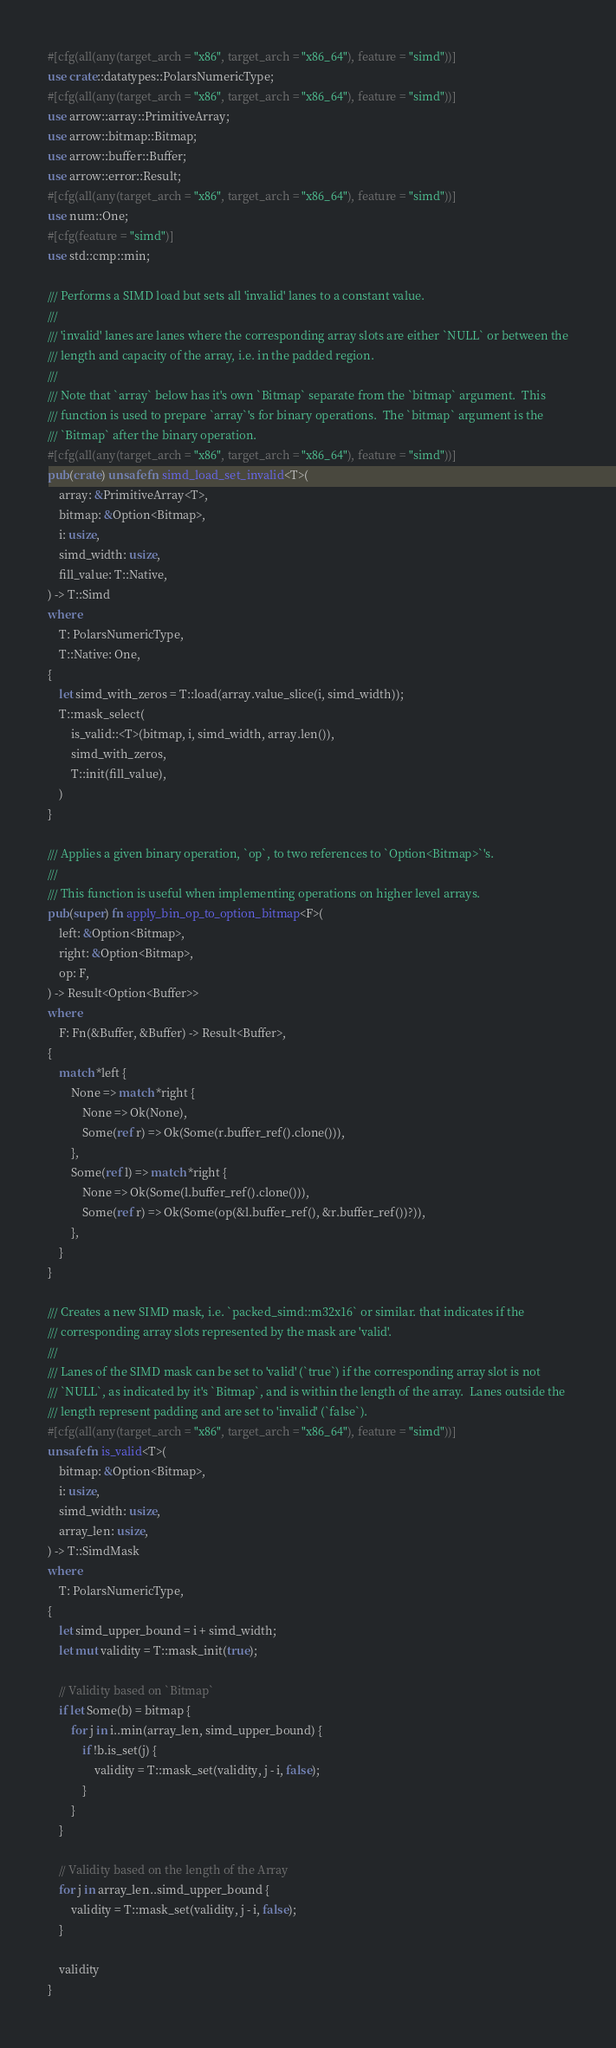Convert code to text. <code><loc_0><loc_0><loc_500><loc_500><_Rust_>#[cfg(all(any(target_arch = "x86", target_arch = "x86_64"), feature = "simd"))]
use crate::datatypes::PolarsNumericType;
#[cfg(all(any(target_arch = "x86", target_arch = "x86_64"), feature = "simd"))]
use arrow::array::PrimitiveArray;
use arrow::bitmap::Bitmap;
use arrow::buffer::Buffer;
use arrow::error::Result;
#[cfg(all(any(target_arch = "x86", target_arch = "x86_64"), feature = "simd"))]
use num::One;
#[cfg(feature = "simd")]
use std::cmp::min;

/// Performs a SIMD load but sets all 'invalid' lanes to a constant value.
///
/// 'invalid' lanes are lanes where the corresponding array slots are either `NULL` or between the
/// length and capacity of the array, i.e. in the padded region.
///
/// Note that `array` below has it's own `Bitmap` separate from the `bitmap` argument.  This
/// function is used to prepare `array`'s for binary operations.  The `bitmap` argument is the
/// `Bitmap` after the binary operation.
#[cfg(all(any(target_arch = "x86", target_arch = "x86_64"), feature = "simd"))]
pub(crate) unsafe fn simd_load_set_invalid<T>(
    array: &PrimitiveArray<T>,
    bitmap: &Option<Bitmap>,
    i: usize,
    simd_width: usize,
    fill_value: T::Native,
) -> T::Simd
where
    T: PolarsNumericType,
    T::Native: One,
{
    let simd_with_zeros = T::load(array.value_slice(i, simd_width));
    T::mask_select(
        is_valid::<T>(bitmap, i, simd_width, array.len()),
        simd_with_zeros,
        T::init(fill_value),
    )
}

/// Applies a given binary operation, `op`, to two references to `Option<Bitmap>`'s.
///
/// This function is useful when implementing operations on higher level arrays.
pub(super) fn apply_bin_op_to_option_bitmap<F>(
    left: &Option<Bitmap>,
    right: &Option<Bitmap>,
    op: F,
) -> Result<Option<Buffer>>
where
    F: Fn(&Buffer, &Buffer) -> Result<Buffer>,
{
    match *left {
        None => match *right {
            None => Ok(None),
            Some(ref r) => Ok(Some(r.buffer_ref().clone())),
        },
        Some(ref l) => match *right {
            None => Ok(Some(l.buffer_ref().clone())),
            Some(ref r) => Ok(Some(op(&l.buffer_ref(), &r.buffer_ref())?)),
        },
    }
}

/// Creates a new SIMD mask, i.e. `packed_simd::m32x16` or similar. that indicates if the
/// corresponding array slots represented by the mask are 'valid'.
///
/// Lanes of the SIMD mask can be set to 'valid' (`true`) if the corresponding array slot is not
/// `NULL`, as indicated by it's `Bitmap`, and is within the length of the array.  Lanes outside the
/// length represent padding and are set to 'invalid' (`false`).
#[cfg(all(any(target_arch = "x86", target_arch = "x86_64"), feature = "simd"))]
unsafe fn is_valid<T>(
    bitmap: &Option<Bitmap>,
    i: usize,
    simd_width: usize,
    array_len: usize,
) -> T::SimdMask
where
    T: PolarsNumericType,
{
    let simd_upper_bound = i + simd_width;
    let mut validity = T::mask_init(true);

    // Validity based on `Bitmap`
    if let Some(b) = bitmap {
        for j in i..min(array_len, simd_upper_bound) {
            if !b.is_set(j) {
                validity = T::mask_set(validity, j - i, false);
            }
        }
    }

    // Validity based on the length of the Array
    for j in array_len..simd_upper_bound {
        validity = T::mask_set(validity, j - i, false);
    }

    validity
}
</code> 